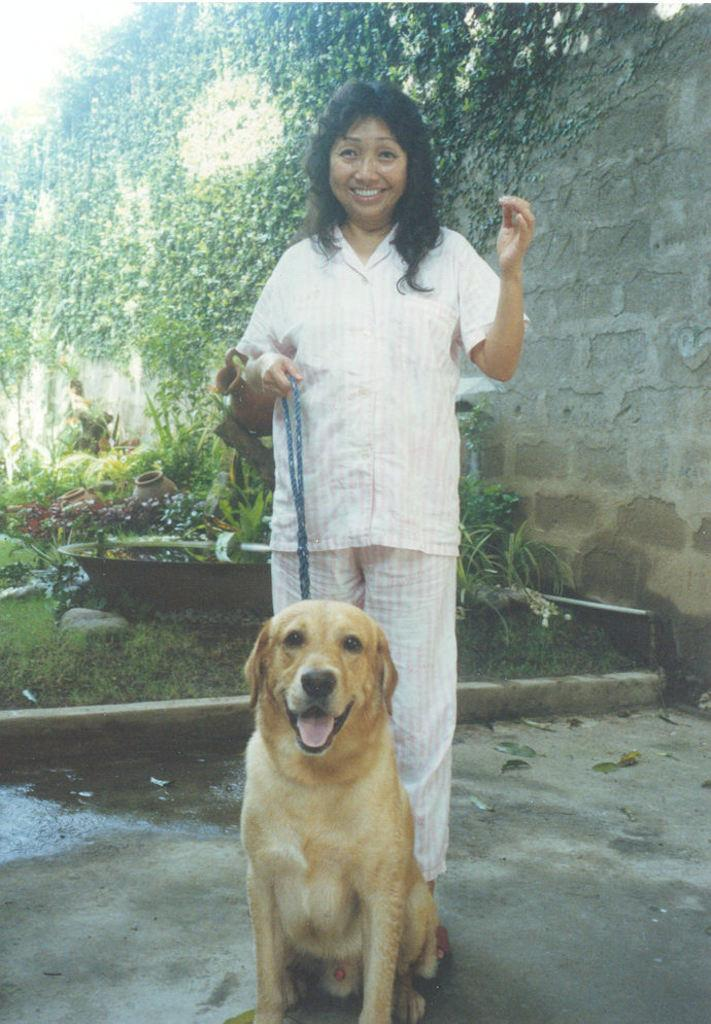What is the main subject of the image? There is a woman in the image. What is the woman doing in the image? The woman is standing and holding a dog's chain. What can be seen in the background of the image? There are trees, plants, and a brick wall in the background of the image. What type of orange is being served at the party in the image? There is no party or orange present in the image. What rule is being enforced by the woman in the image? There is no indication of a rule being enforced in the image; the woman is simply holding a dog's chain. 